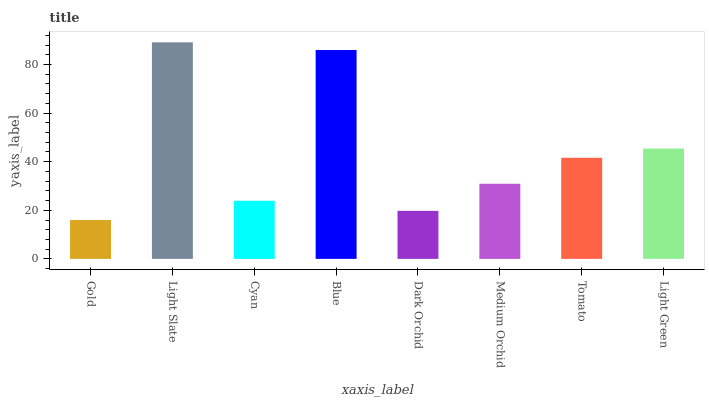Is Gold the minimum?
Answer yes or no. Yes. Is Light Slate the maximum?
Answer yes or no. Yes. Is Cyan the minimum?
Answer yes or no. No. Is Cyan the maximum?
Answer yes or no. No. Is Light Slate greater than Cyan?
Answer yes or no. Yes. Is Cyan less than Light Slate?
Answer yes or no. Yes. Is Cyan greater than Light Slate?
Answer yes or no. No. Is Light Slate less than Cyan?
Answer yes or no. No. Is Tomato the high median?
Answer yes or no. Yes. Is Medium Orchid the low median?
Answer yes or no. Yes. Is Medium Orchid the high median?
Answer yes or no. No. Is Blue the low median?
Answer yes or no. No. 